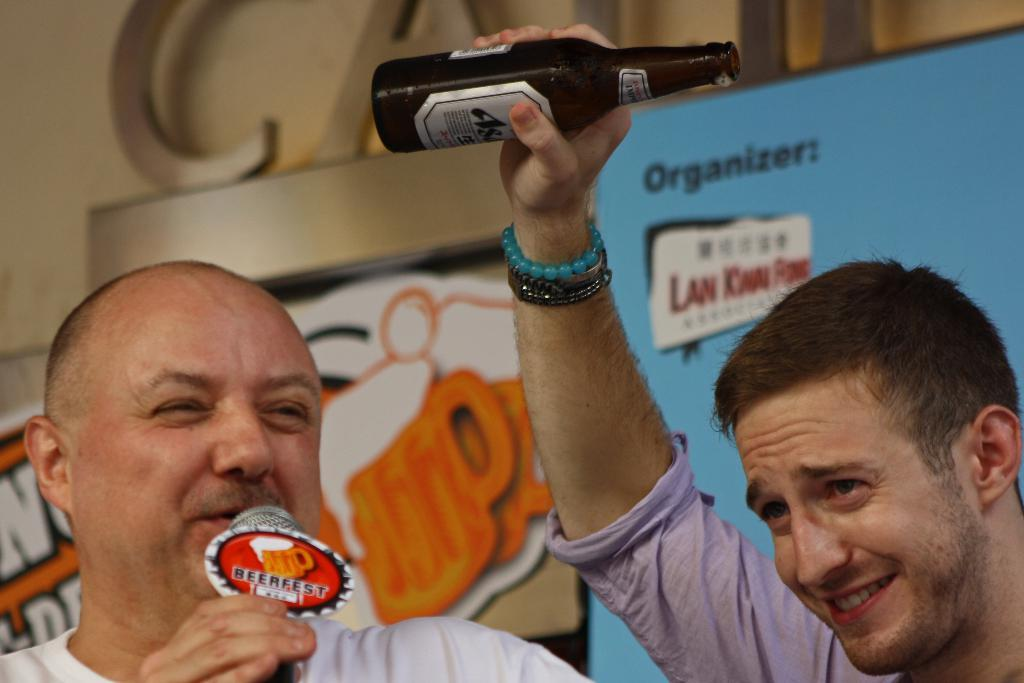How many people are in the image? There are two people in the image. What are the two people holding? One person is holding a bottle, and the other person is holding a microphone. What can be seen in the background of the image? There are boards with text in the background of the image. What type of wren can be seen perched on the microphone in the image? There is no wren present in the image; it features two people holding a bottle and a microphone, with boards with text in the background. 